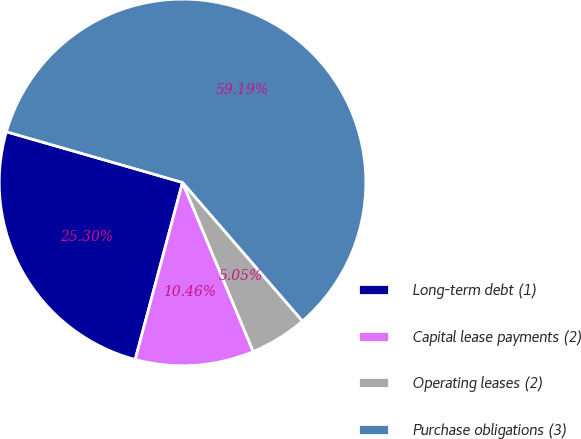Convert chart. <chart><loc_0><loc_0><loc_500><loc_500><pie_chart><fcel>Long-term debt (1)<fcel>Capital lease payments (2)<fcel>Operating leases (2)<fcel>Purchase obligations (3)<nl><fcel>25.3%<fcel>10.46%<fcel>5.05%<fcel>59.18%<nl></chart> 